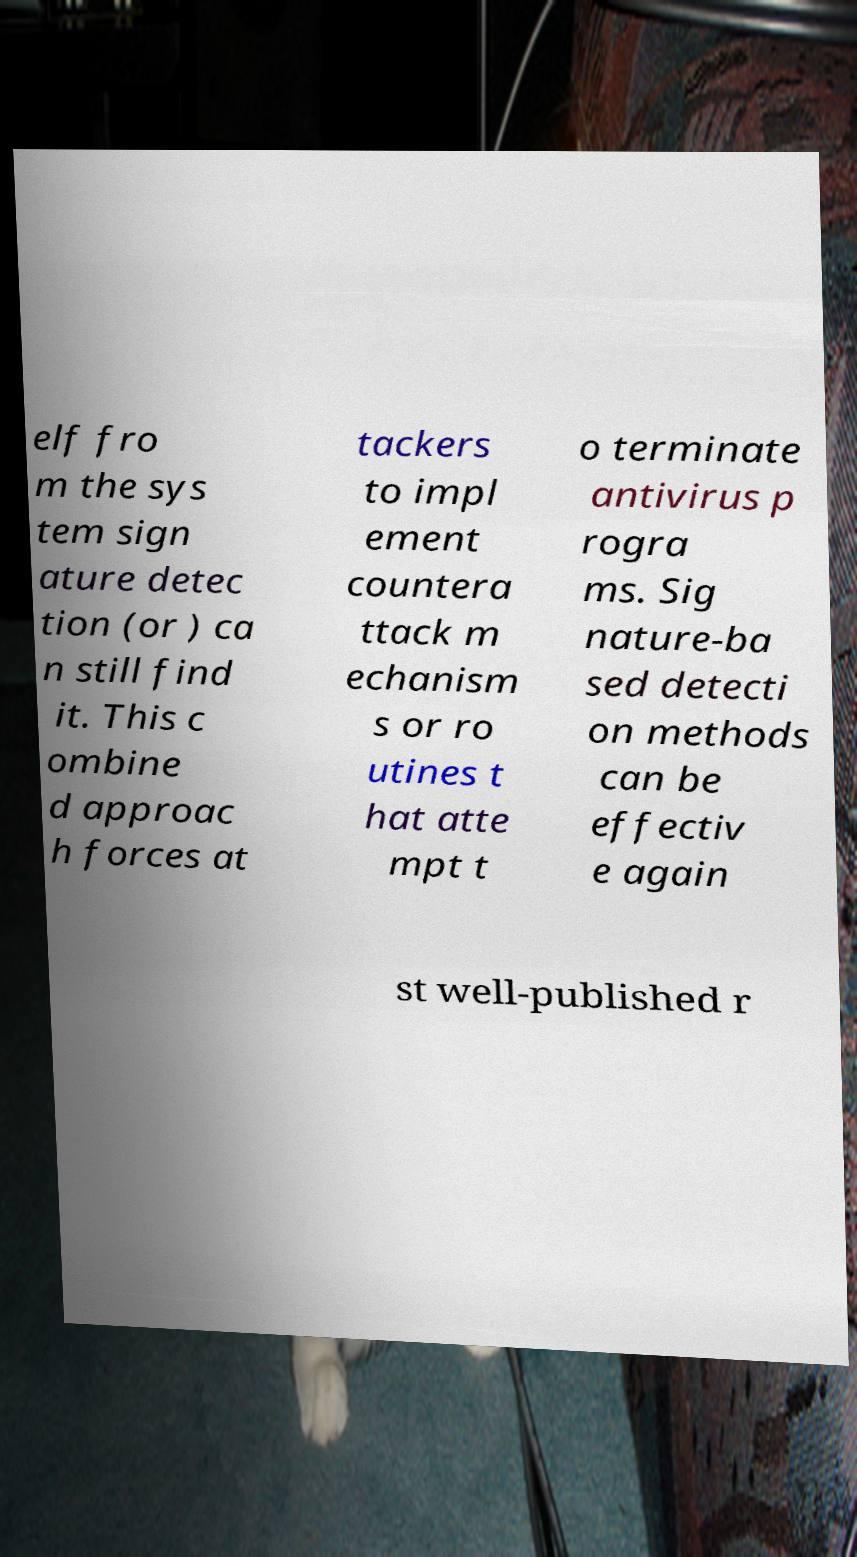Can you read and provide the text displayed in the image?This photo seems to have some interesting text. Can you extract and type it out for me? elf fro m the sys tem sign ature detec tion (or ) ca n still find it. This c ombine d approac h forces at tackers to impl ement countera ttack m echanism s or ro utines t hat atte mpt t o terminate antivirus p rogra ms. Sig nature-ba sed detecti on methods can be effectiv e again st well-published r 